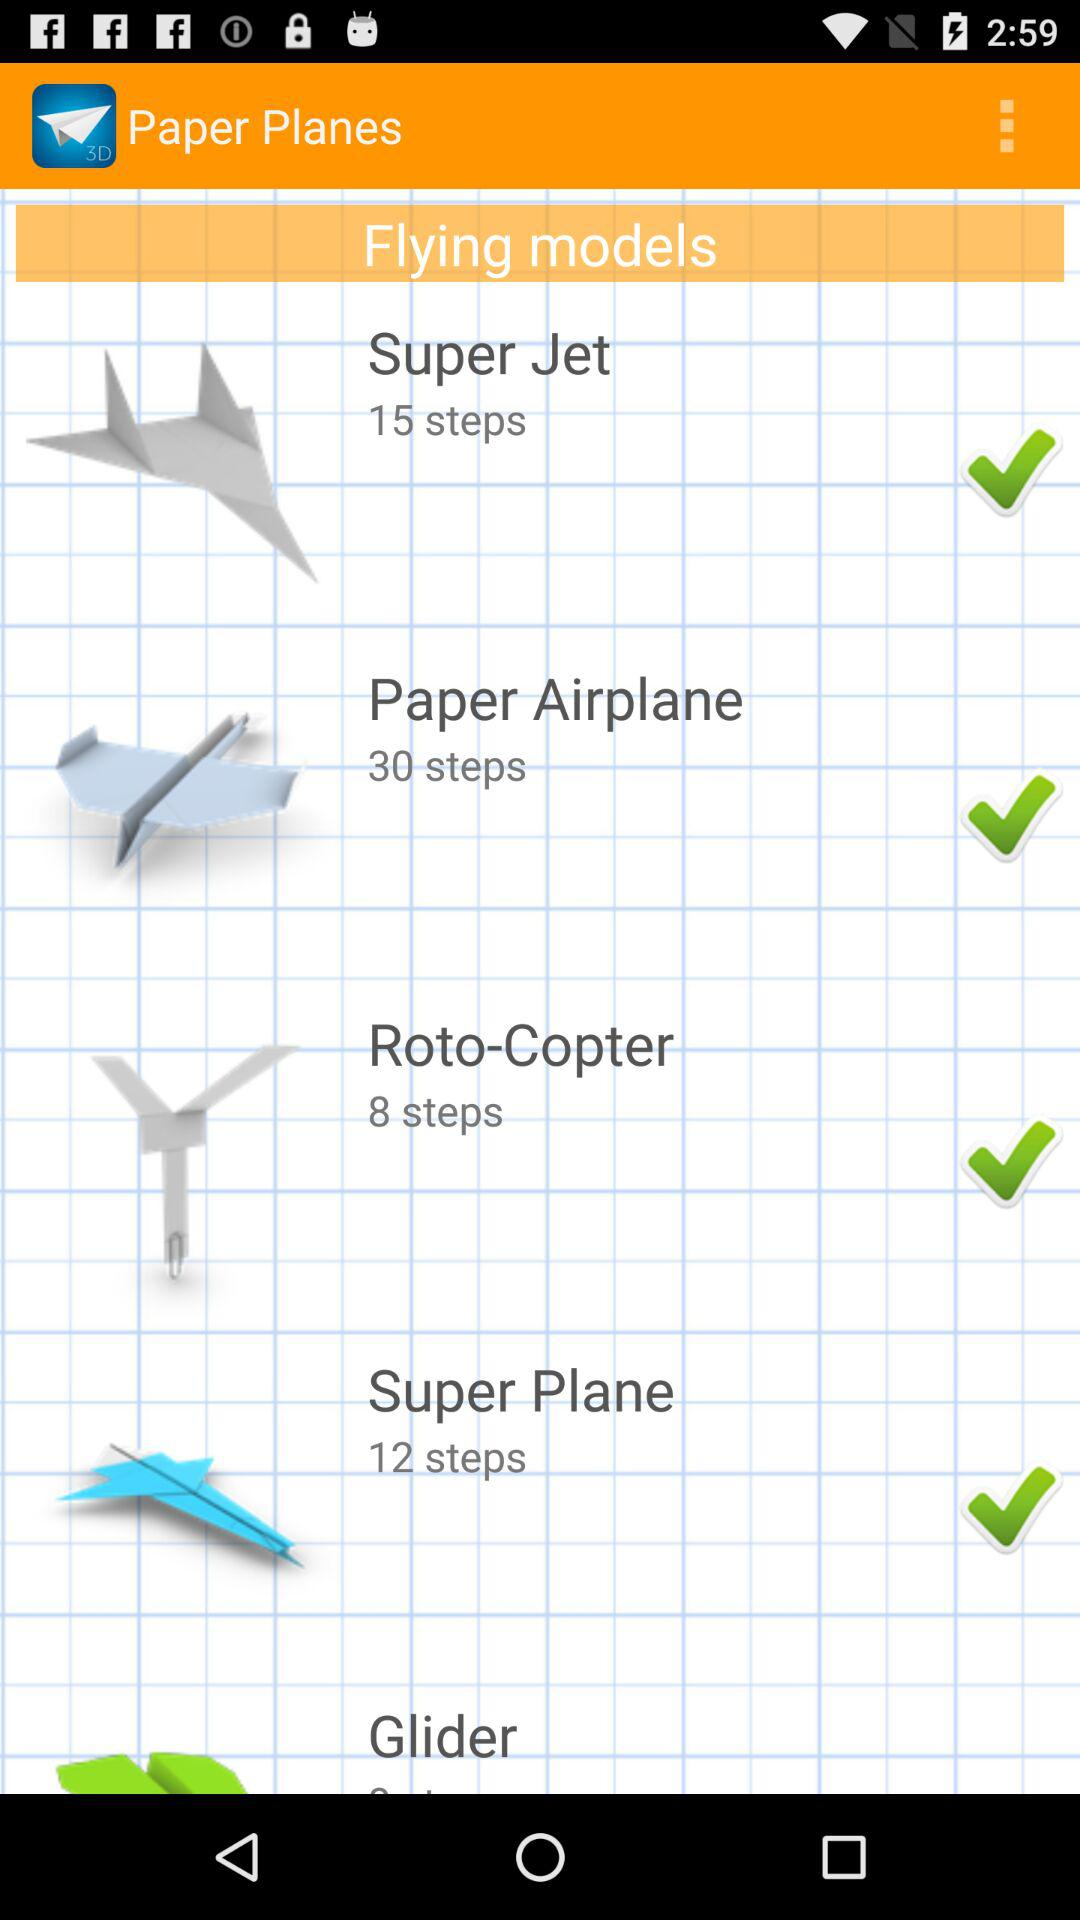How many steps are there to build a "Super Plane"? There are 12 steps to build a "Super Plane". 